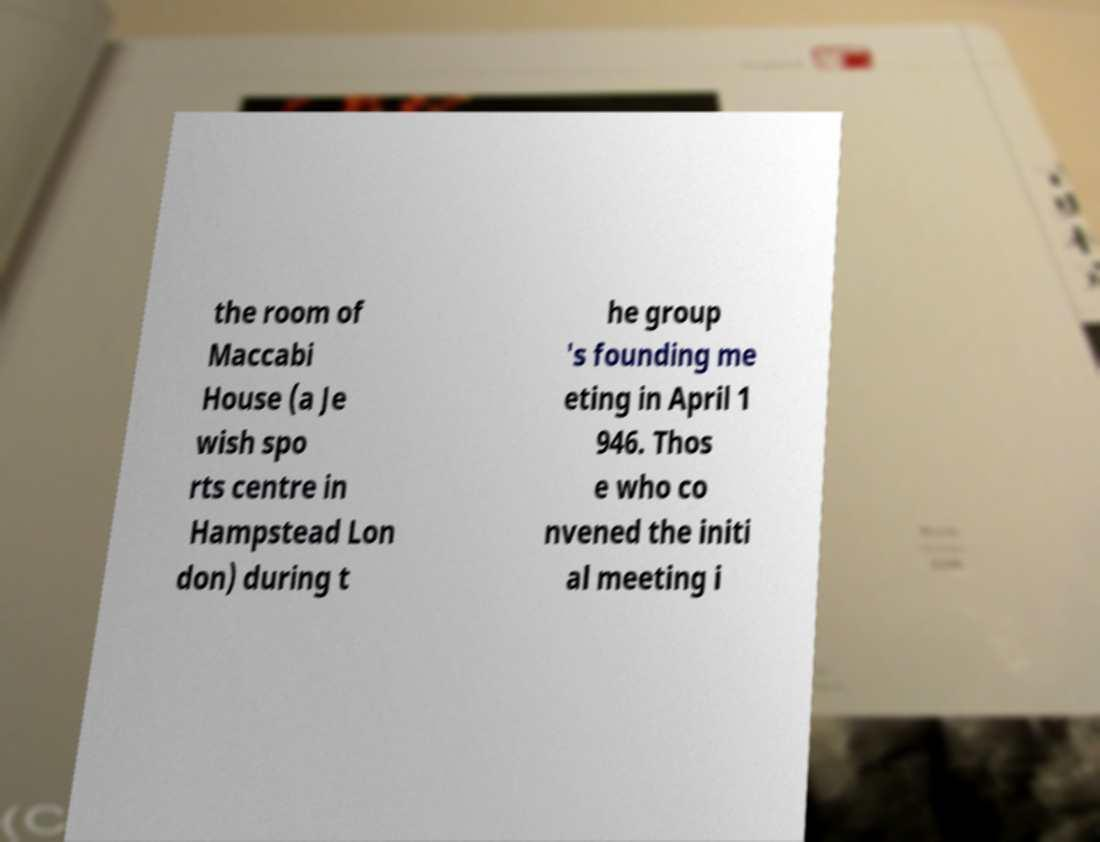There's text embedded in this image that I need extracted. Can you transcribe it verbatim? the room of Maccabi House (a Je wish spo rts centre in Hampstead Lon don) during t he group 's founding me eting in April 1 946. Thos e who co nvened the initi al meeting i 